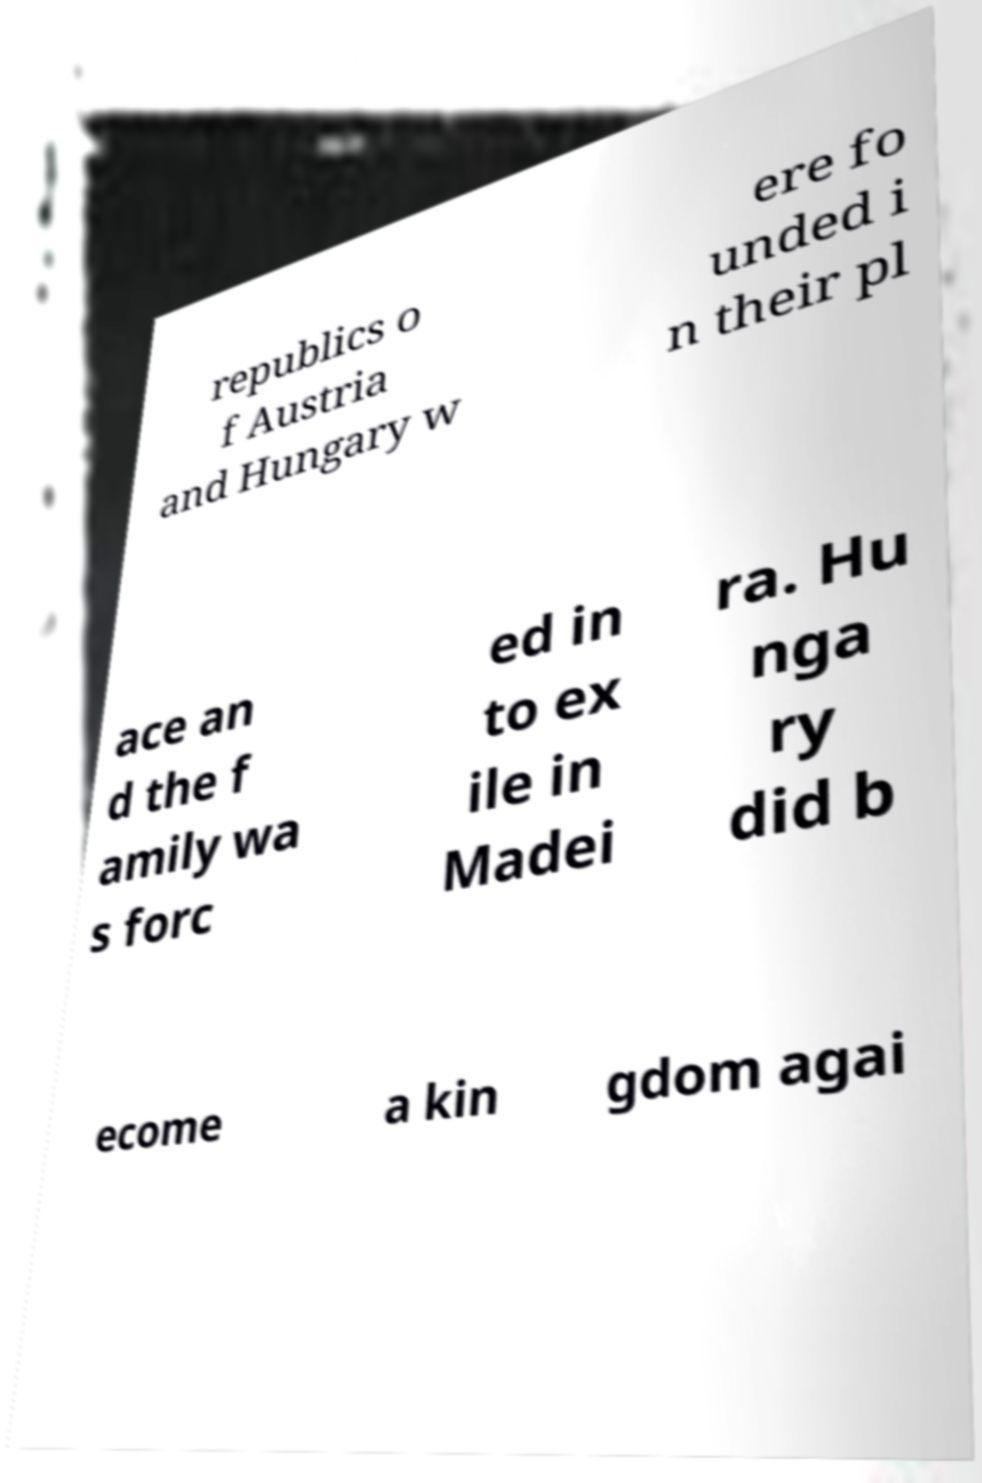There's text embedded in this image that I need extracted. Can you transcribe it verbatim? republics o f Austria and Hungary w ere fo unded i n their pl ace an d the f amily wa s forc ed in to ex ile in Madei ra. Hu nga ry did b ecome a kin gdom agai 